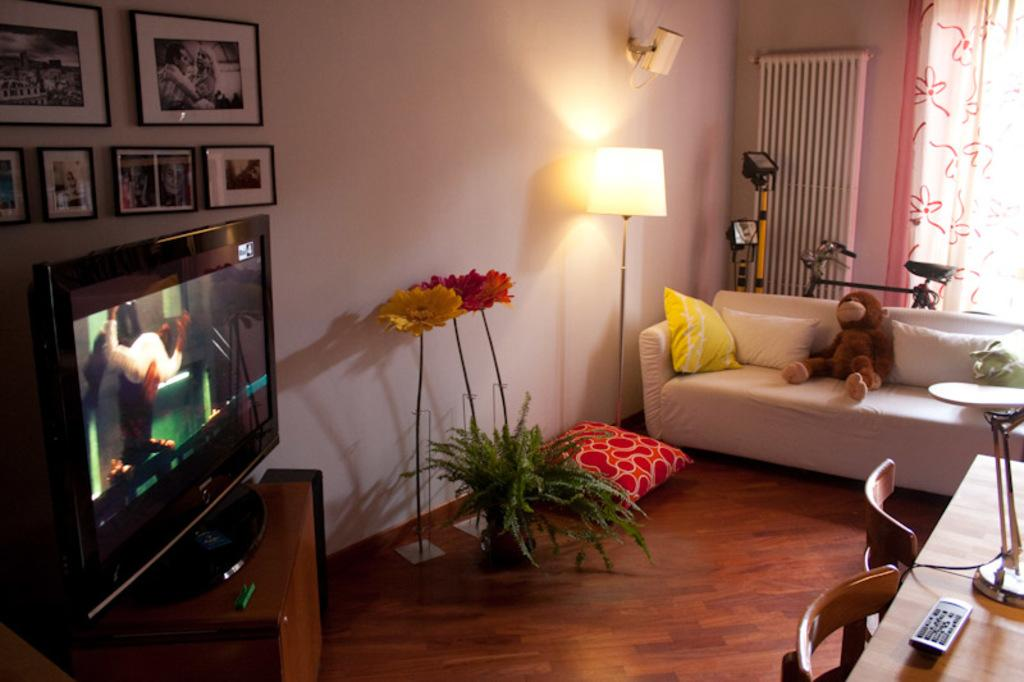What type of electronic device is visible in the image? There is a television in the image. What type of furniture is present in the image? There is a couch, a pillow, a lamp, a table, and a chair in the image. What can be seen attached to the wall in the image? There are frames attached to the wall in the image. How many eggs are on the table in the image? There are no eggs present in the image; the table contains a lamp and other items. 